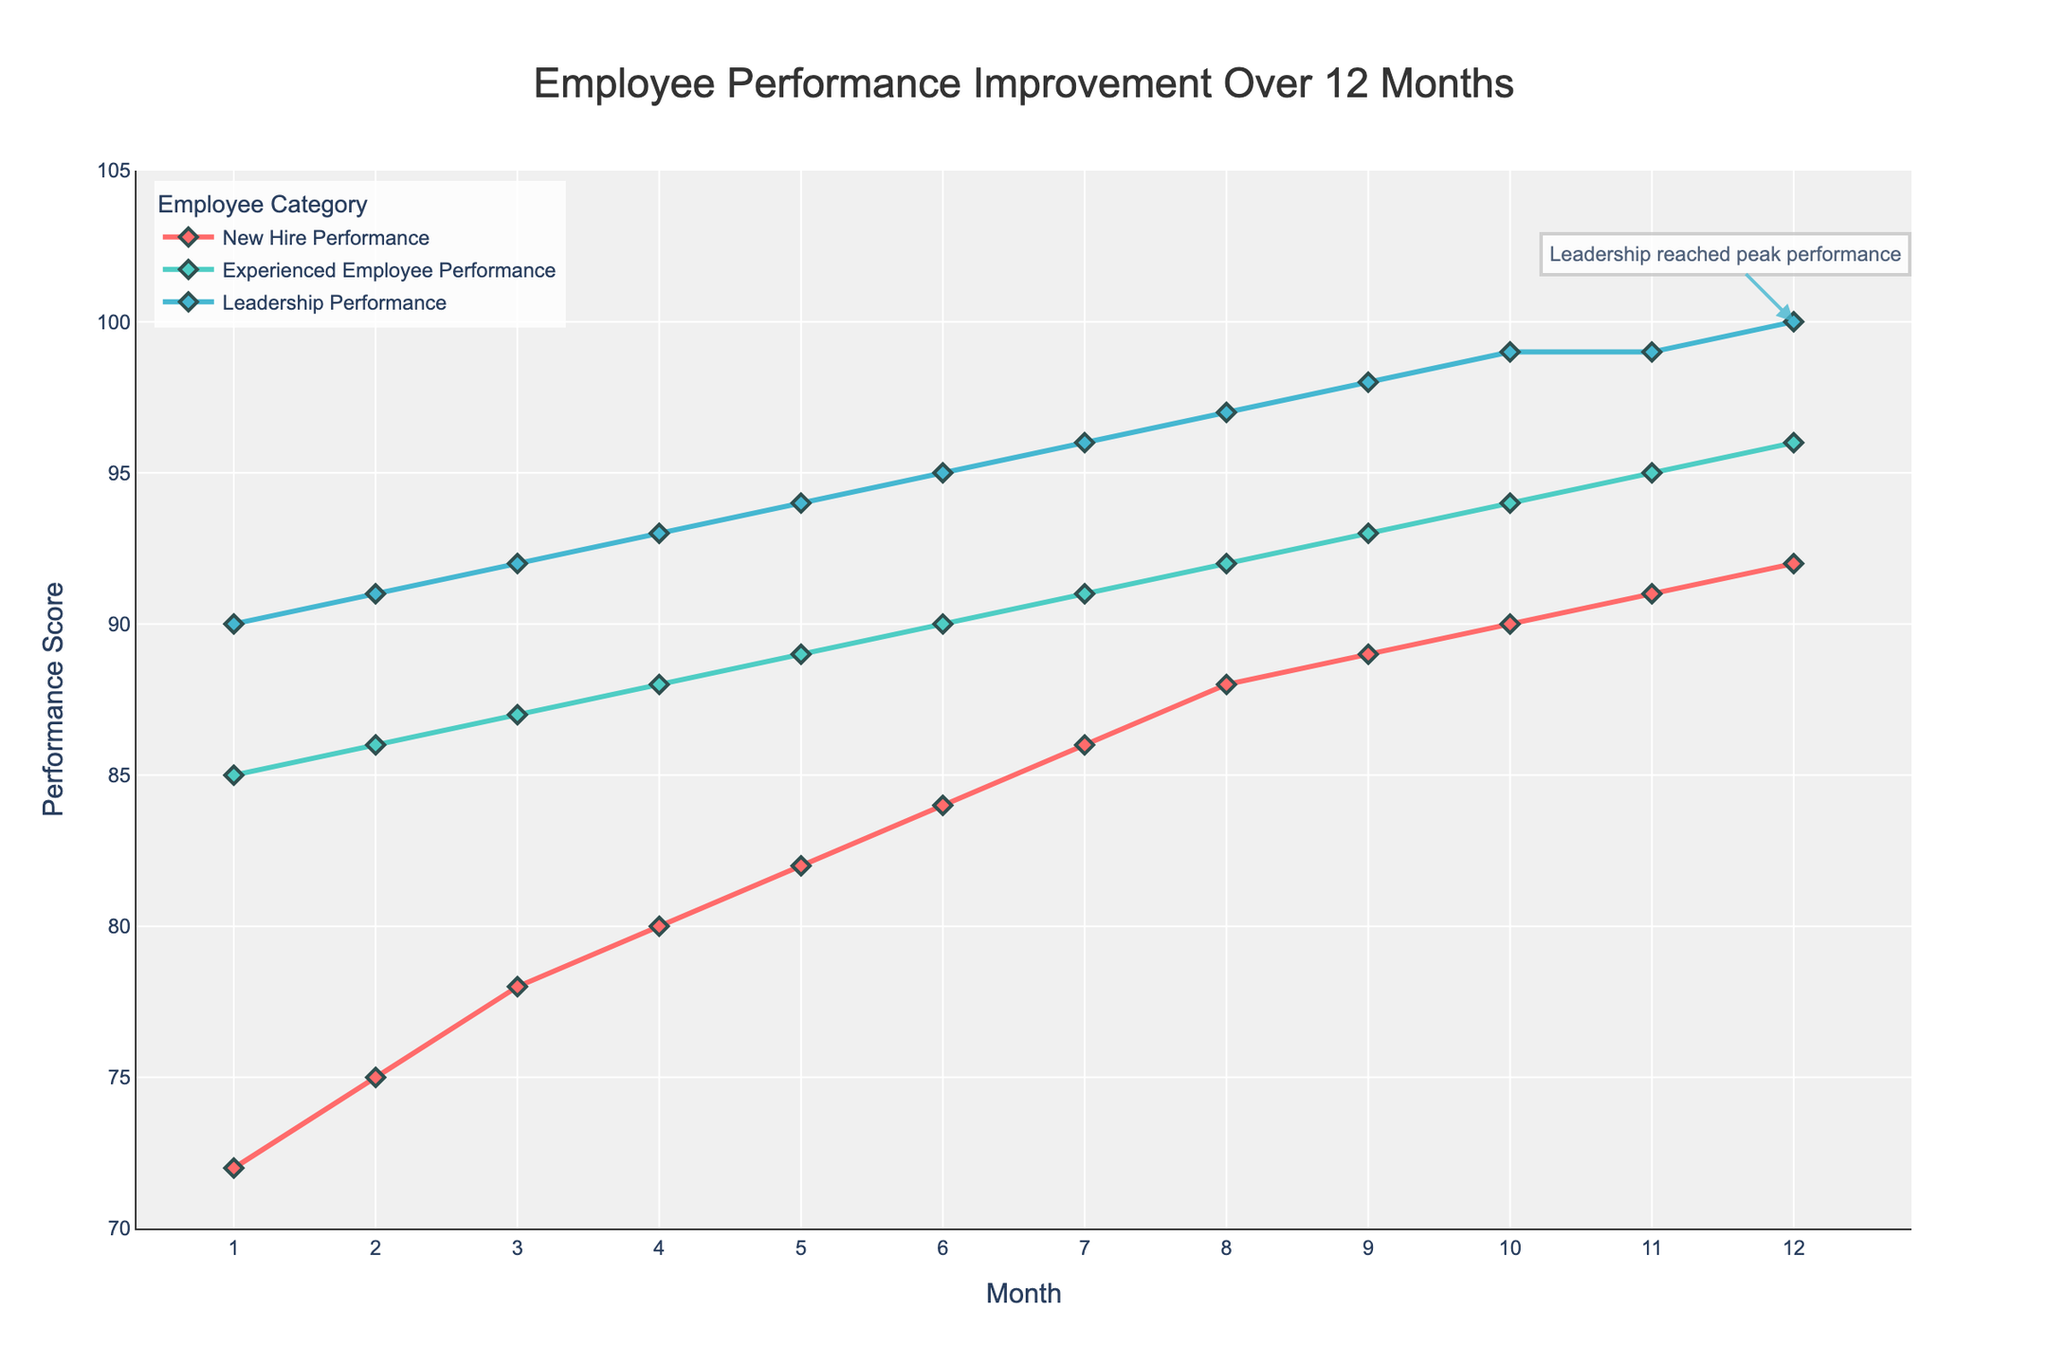what is the difference in performance score between new hires and experienced employees in month 6? In month 6, the performance score for new hires is 84 and for experienced employees is 90. Subtract the new hire score from the experienced employee score: 90 - 84 = 6
Answer: 6 how does the performance score for leadership change from month 9 to month 12? In month 9, the performance score for leadership is 98. In month 12, it is 100. The change is calculated as 100 - 98 = 2
Answer: 2 which month shows the greatest improvement for new hires? The greatest improvement is identified by the largest difference in performance scores between consecutive months. The largest improvement for new hires occurs from month 8 to month 9, where the score increases from 88 to 89, an increase of 1 point. Other months show equal or smaller improvements.
Answer: Month 8 to 9 how do the performance trends of experienced employees and leadership compare over the 12 months? Both experienced employees and leadership show an increasing trend in performance scores over the 12 months. Leadership consistently performs better than experienced employees each month, and the gap between the two categories remains fairly constant.
Answer: Both increasing; leadership always higher which category shows the fastest improvement in the first three months? To determine the fastest improvement, compare the increase in performance scores for each category from month 1 to month 3.
- New hires: 78 - 72 = 6
- Experienced employees: 87 - 85 = 2
- Leadership: 92 - 90 = 2
New hires show the fastest improvement with a score increase of 6.
Answer: New hire what is the overall trend for new hire performance over 12 months? The trend for new hire performance shows a steady increase from 72 in month 1 to 92 in month 12. This consistent upward trend suggests that the training program is effectively improving new hire performance over time.
Answer: Steady increase in which month does experienced employee performance reach or surpass 90? Referring to the trend line for experienced employees, their performance reaches 90 in month 6 and surpasses it in all subsequent months.
Answer: Month 6 how does the performance of new hires in month 12 compare to the performance of experienced employees in month 6? Performance score for new hires in month 12 is 92, while for experienced employees in month 6, it is 90. The new hire performance is 2 points higher.
Answer: New hires higher by 2 points which category shows the smallest variability in performance improvements over the 12 months? To analyze variability, observe the fluctuations in the performance trend lines. Leadership shows the smallest variability with a consistent and gradual increase, with performance scores ranging narrowly from 90 to 100.
Answer: Leadership how does the visual annotation indicate key insights about leadership performance? The visual annotation highlights that leadership reached peak performance in month 12, with a performance score of 100. This annotation underscores the effectiveness of the leadership training program by marking the significant achievement visually.
Answer: Leadership peak at month 12 